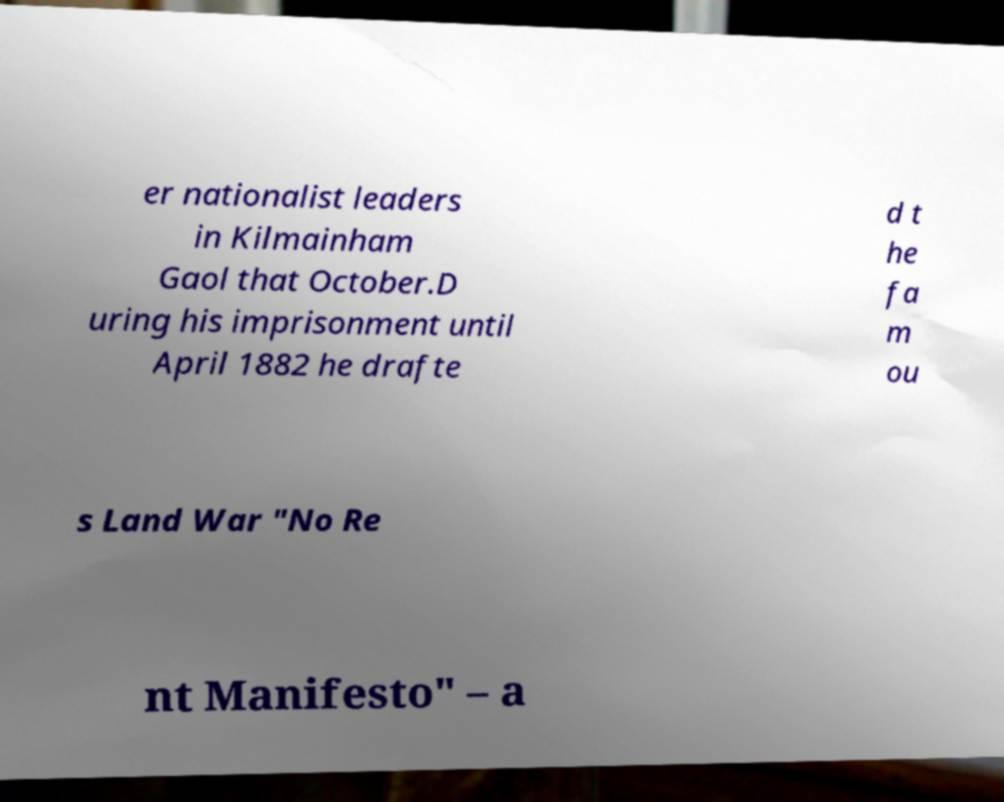Please read and relay the text visible in this image. What does it say? er nationalist leaders in Kilmainham Gaol that October.D uring his imprisonment until April 1882 he drafte d t he fa m ou s Land War "No Re nt Manifesto" – a 